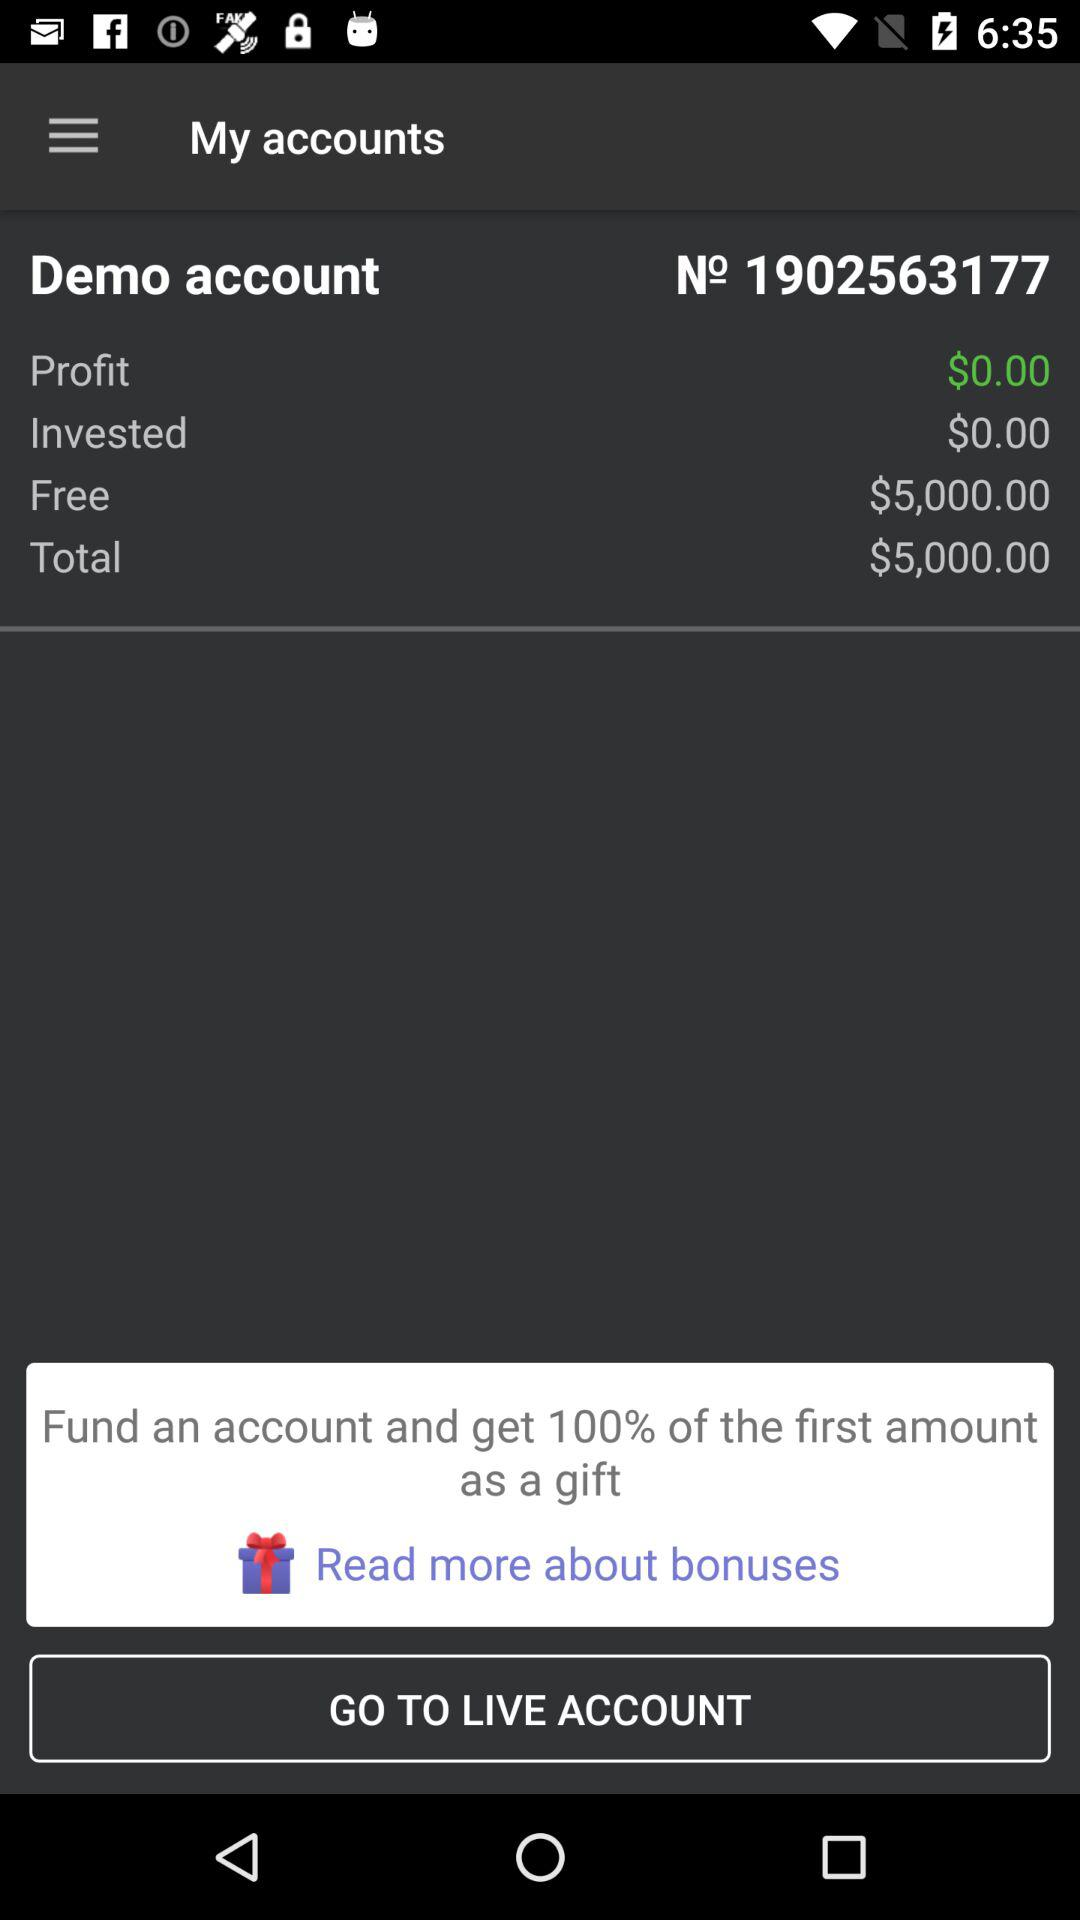What is the demo account number? The demo account number is 1902563177. 